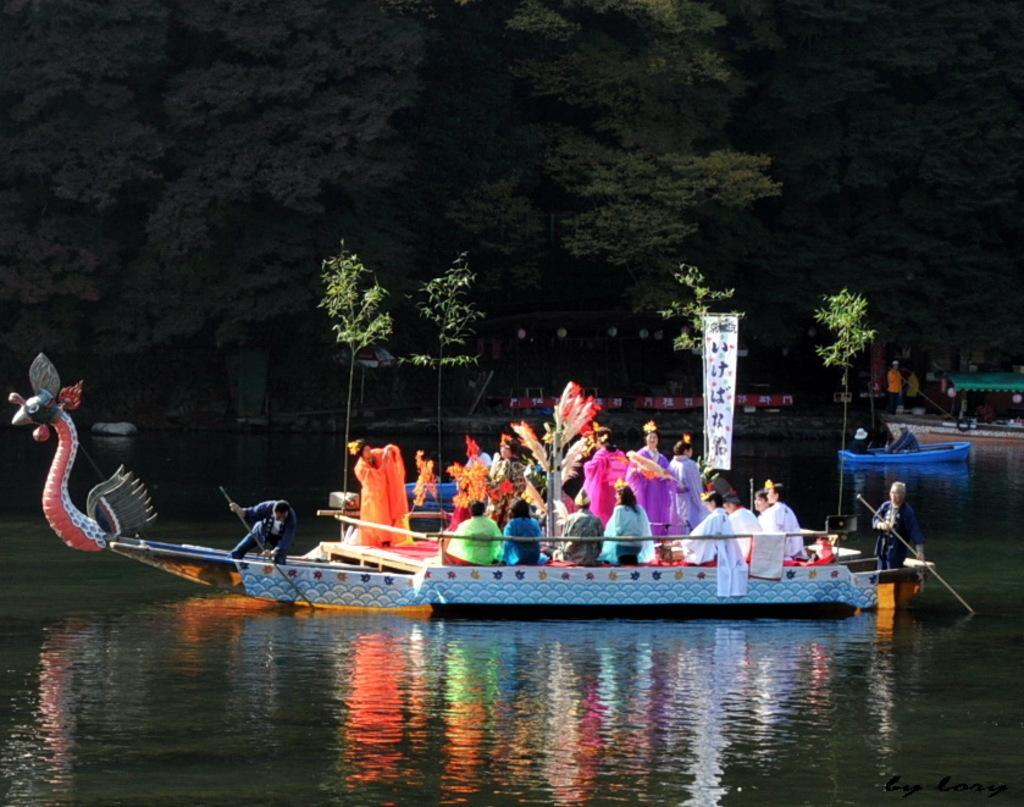Could you give a brief overview of what you see in this image? At the bottom of the image we can see water, above the water there are some boats. In the boats few people are sitting and standing and there are some banners and trees. At the top of the image there are some trees. 